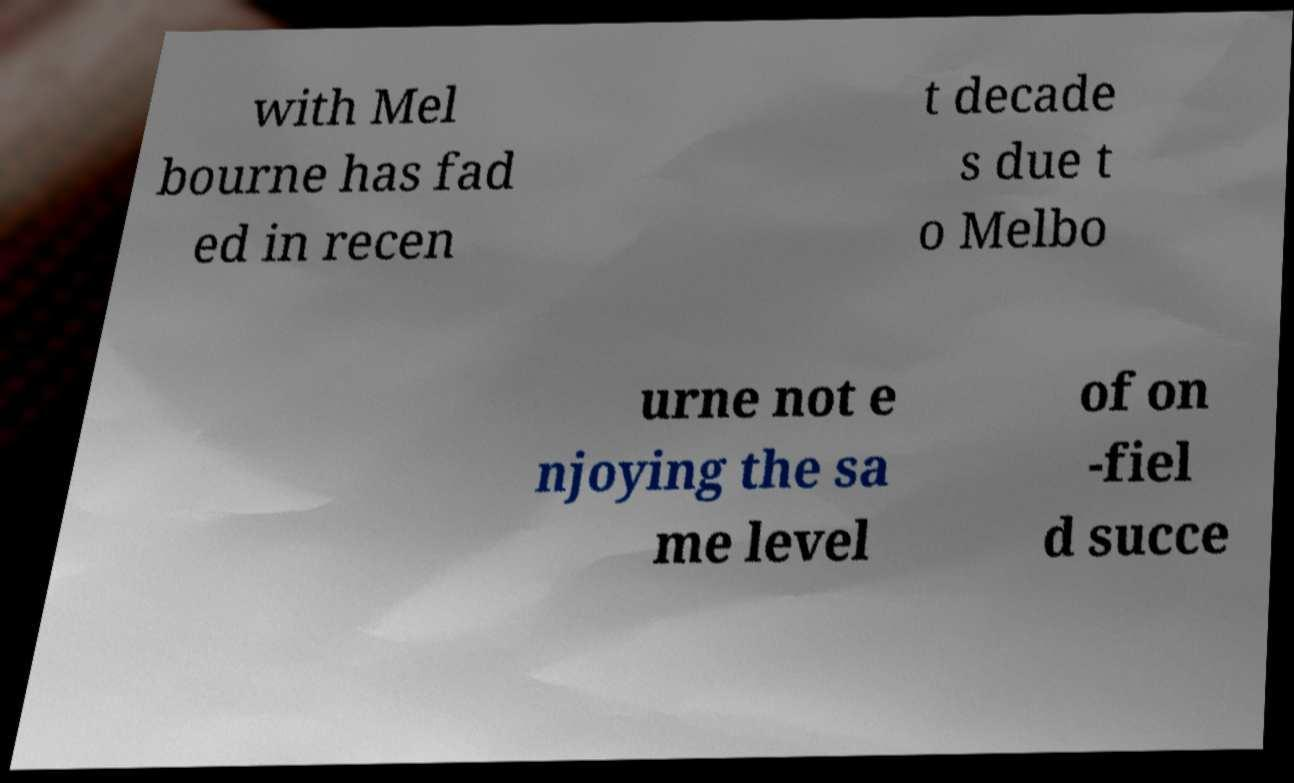Can you read and provide the text displayed in the image?This photo seems to have some interesting text. Can you extract and type it out for me? with Mel bourne has fad ed in recen t decade s due t o Melbo urne not e njoying the sa me level of on -fiel d succe 